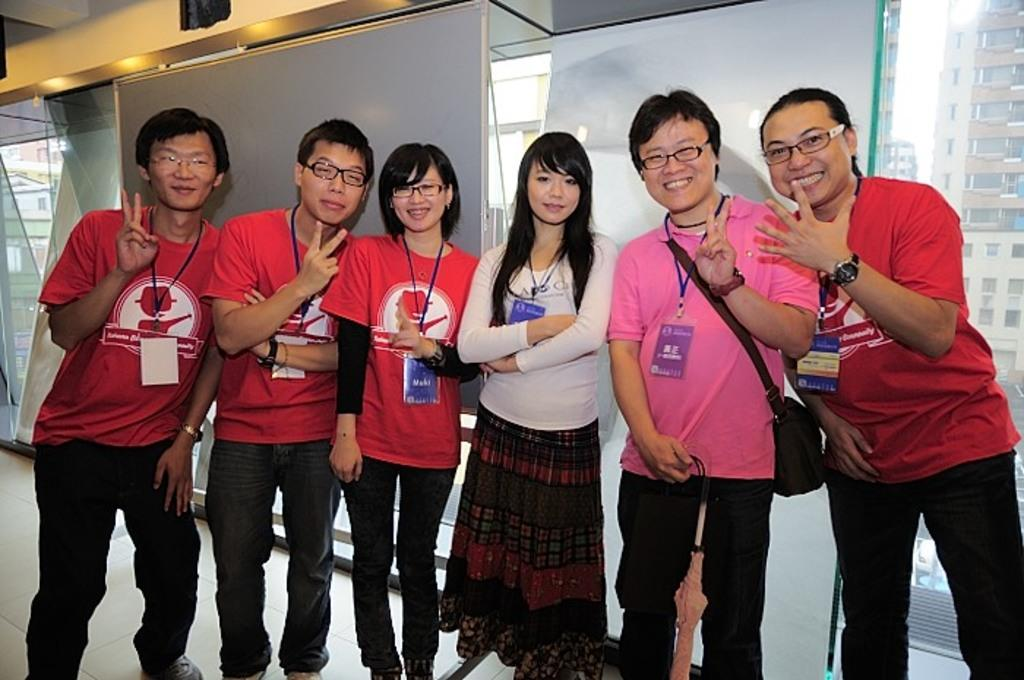How many people are in the image? There is a group of people standing in the image. Where are the people standing? The people are standing on the floor. What can be seen in the image besides the people? There is a board visible in the image. What type of structure is present in the image? There is a building with windows in the image, and it has a roof. What direction is the goose flying in the image? There is no goose present in the image, so it is not possible to determine the direction in which it might be flying. 